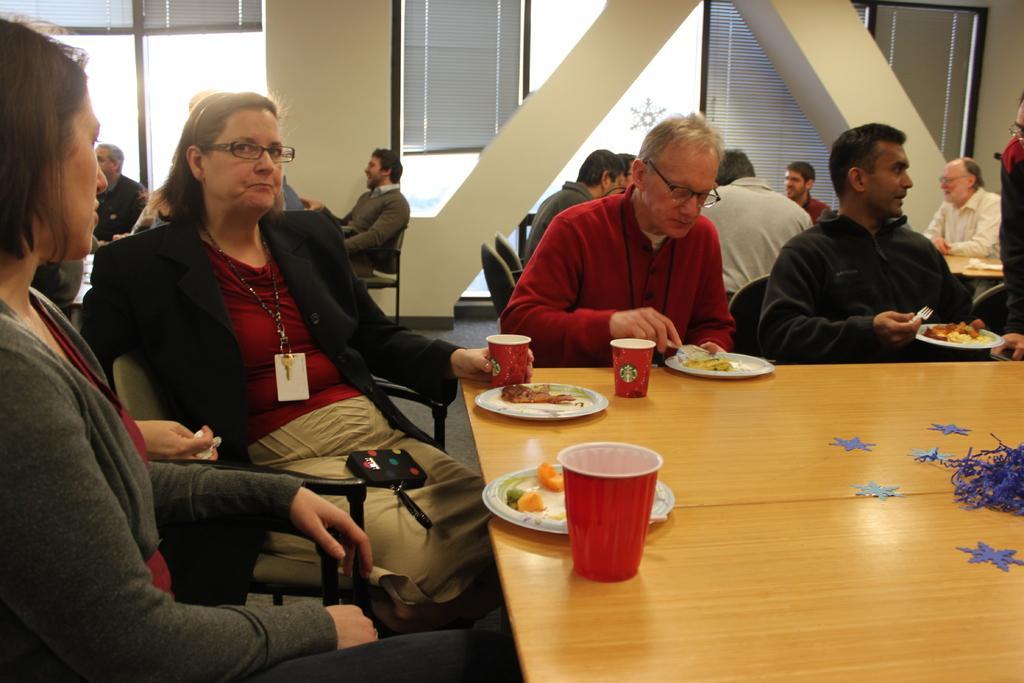Please provide a concise description of this image. This picture describe the inside view of the hall in which group of people are sitting around the table and having the snack and drinks, In front we can see woman sitting and wearing black jacket with id card in neck is seeing towards the camera, Beside another man eating , Behind we can see other person on the table. Behind Two arch pillar and glass windows. 